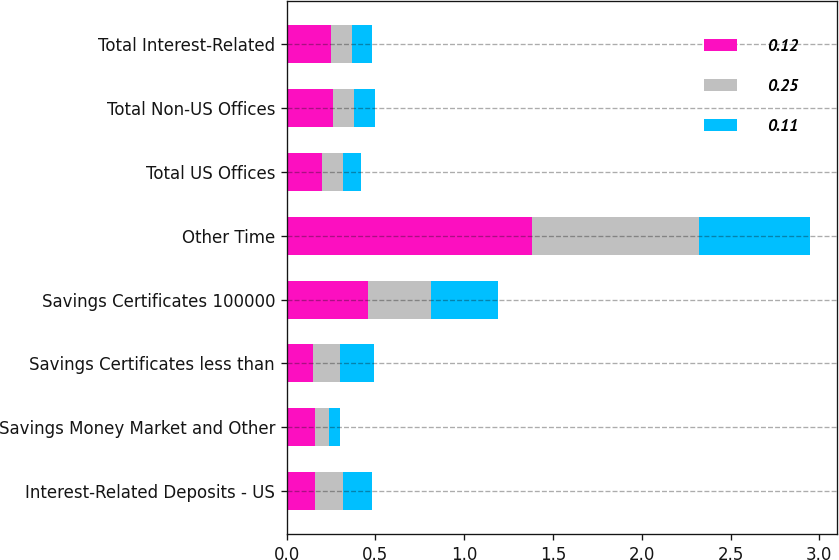Convert chart. <chart><loc_0><loc_0><loc_500><loc_500><stacked_bar_chart><ecel><fcel>Interest-Related Deposits - US<fcel>Savings Money Market and Other<fcel>Savings Certificates less than<fcel>Savings Certificates 100000<fcel>Other Time<fcel>Total US Offices<fcel>Total Non-US Offices<fcel>Total Interest-Related<nl><fcel>0.12<fcel>0.16<fcel>0.16<fcel>0.15<fcel>0.46<fcel>1.38<fcel>0.2<fcel>0.26<fcel>0.25<nl><fcel>0.25<fcel>0.16<fcel>0.08<fcel>0.15<fcel>0.35<fcel>0.94<fcel>0.12<fcel>0.12<fcel>0.12<nl><fcel>0.11<fcel>0.16<fcel>0.06<fcel>0.19<fcel>0.38<fcel>0.63<fcel>0.1<fcel>0.12<fcel>0.11<nl></chart> 